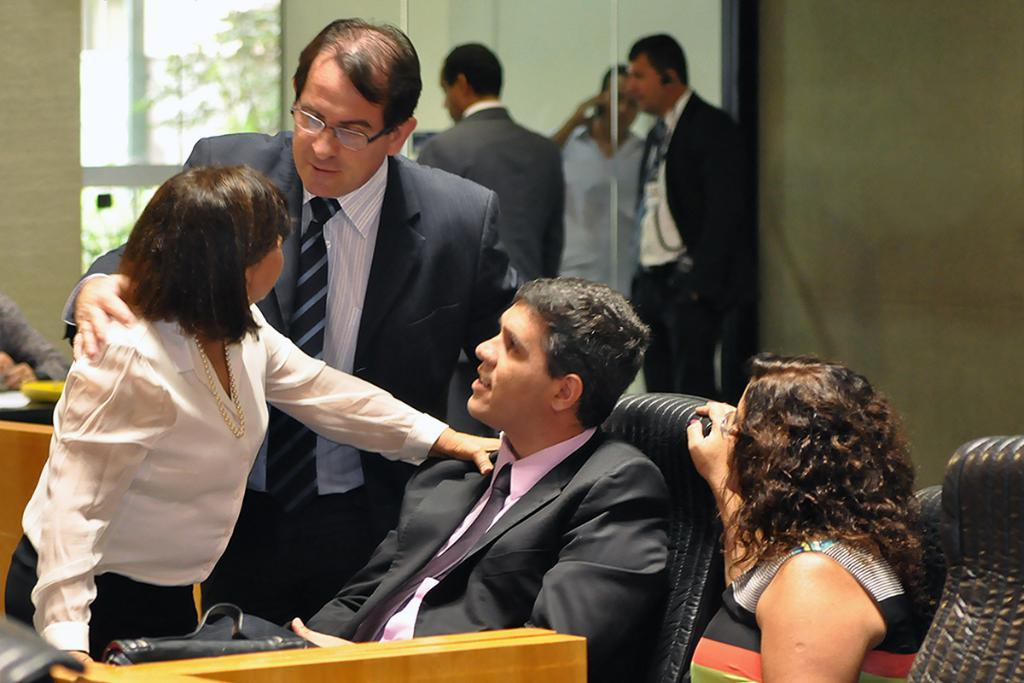What are the persons in the image doing? Some persons are sitting on chairs, while others are standing in the image. What can be seen in the background of the image? There is a wall and a glass door in the background of the image. What is the average income of the society depicted in the image? There is no information about the income or society of the persons in the image, as the facts provided only mention their positions and the presence of a wall and glass door in the background. 